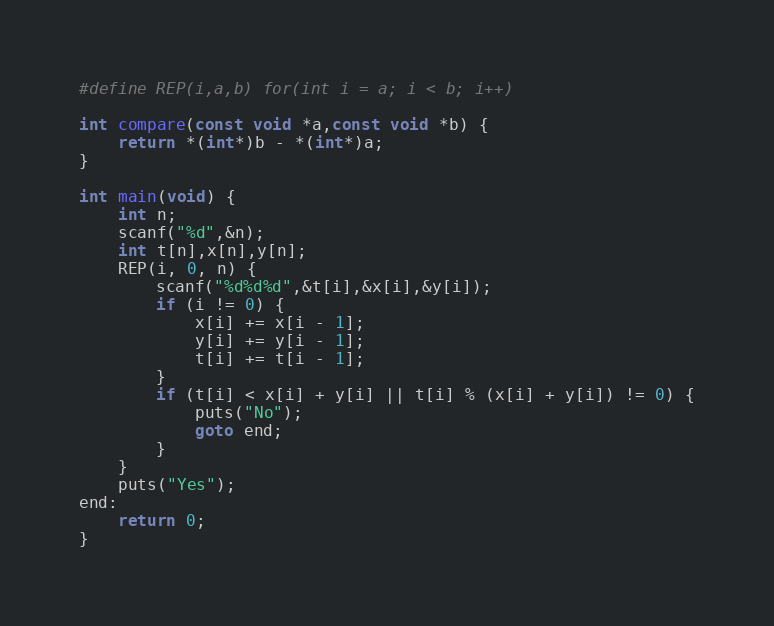<code> <loc_0><loc_0><loc_500><loc_500><_C_>#define REP(i,a,b) for(int i = a; i < b; i++)

int compare(const void *a,const void *b) {
    return *(int*)b - *(int*)a;
}

int main(void) {
    int n;
    scanf("%d",&n);
    int t[n],x[n],y[n];
    REP(i, 0, n) {
        scanf("%d%d%d",&t[i],&x[i],&y[i]);
        if (i != 0) {
            x[i] += x[i - 1];
            y[i] += y[i - 1];
            t[i] += t[i - 1];
        }
        if (t[i] < x[i] + y[i] || t[i] % (x[i] + y[i]) != 0) {
            puts("No");
            goto end;
        }
    }
    puts("Yes");
end:
    return 0;
}</code> 